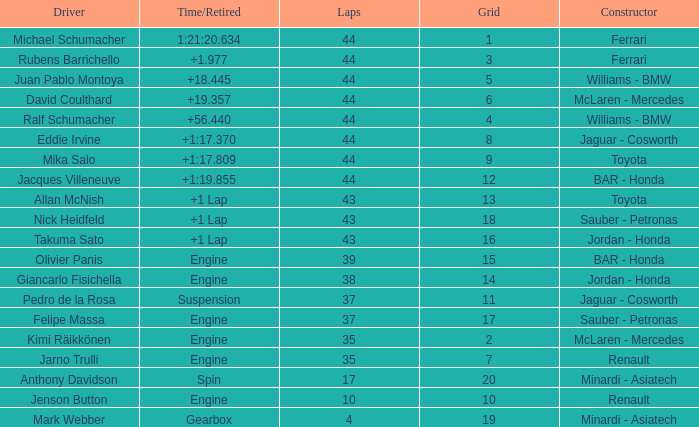What was the time of the driver on grid 3? 1.977. 